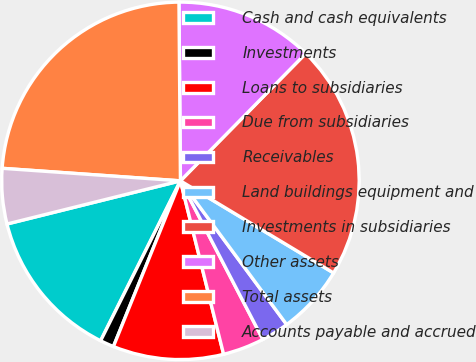Convert chart to OTSL. <chart><loc_0><loc_0><loc_500><loc_500><pie_chart><fcel>Cash and cash equivalents<fcel>Investments<fcel>Loans to subsidiaries<fcel>Due from subsidiaries<fcel>Receivables<fcel>Land buildings equipment and<fcel>Investments in subsidiaries<fcel>Other assets<fcel>Total assets<fcel>Accounts payable and accrued<nl><fcel>13.75%<fcel>1.25%<fcel>10.0%<fcel>3.75%<fcel>2.5%<fcel>6.25%<fcel>21.25%<fcel>12.5%<fcel>23.75%<fcel>5.0%<nl></chart> 